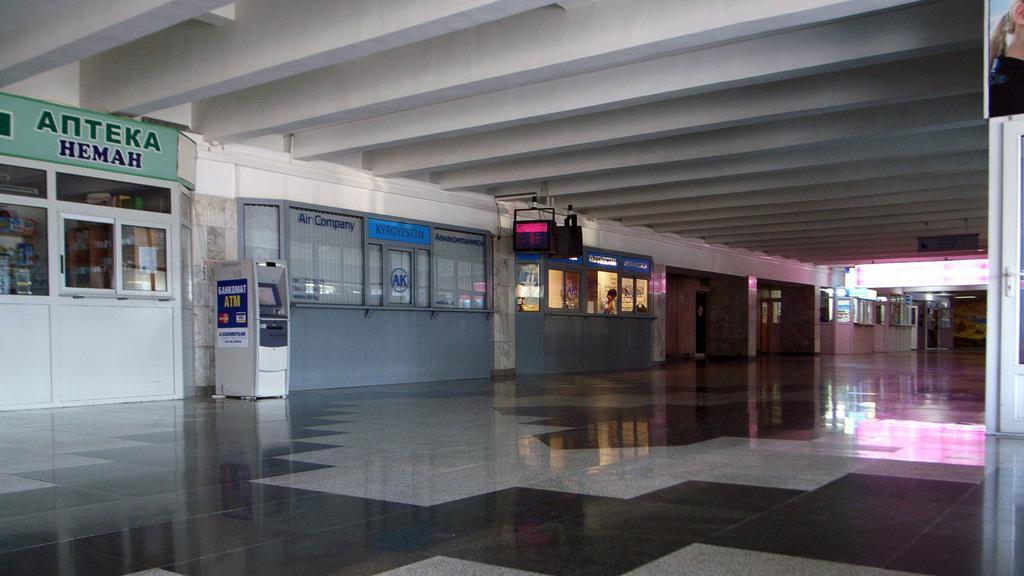Can you describe this image briefly? In this picture we can see ATM machine which is near to the door. Here we can see a man who is standing inside the shop. On the top left there is a board. On the right background we can see doors, windows and lights. Here we can see a screen. On the top left corner there is a poster. On the bottom we can see a granite floor. 